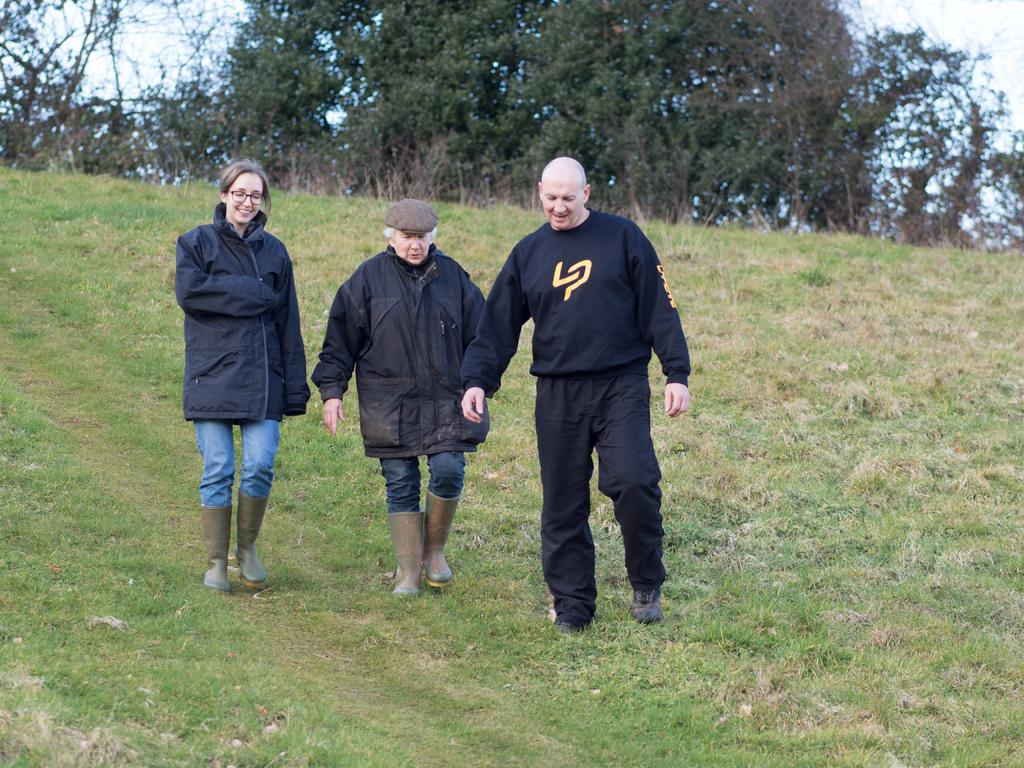How many people are in the image? There are two men and one woman in the image. What are the individuals doing in the image? The individuals are walking on a grass surface hill. What are the individuals wearing in the image? The individuals are wearing black jackets. What can be seen in the background of the image? There are trees and the sky visible in the background of the image. What type of dinosaur can be seen in the image? There are no dinosaurs present in the image. Can you tell me which insurance company the individuals are affiliated with in the image? There is no information about insurance companies in the image. 